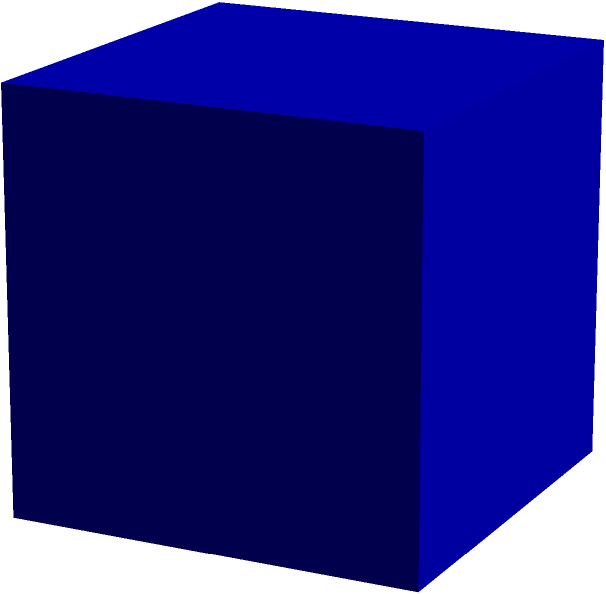In your book club, you're using a cube-shaped display box to showcase a special edition memory book. If the edge length of this cube is $a$ units, what is the volume of the display box? To calculate the volume of a cube, we follow these steps:

1. Identify the formula for the volume of a cube:
   The volume of a cube is given by $V = a^3$, where $a$ is the length of an edge.

2. Understand why this formula works:
   - A cube has three dimensions: length, width, and height.
   - In a cube, all these dimensions are equal to the edge length $a$.
   - To find the volume, we multiply these three dimensions: $a \times a \times a = a^3$

3. Apply the formula:
   - We're given that the edge length is $a$ units.
   - Substituting this into our formula: $V = a^3$

4. Interpret the result:
   - This means that for any edge length $a$, the volume will be $a$ cubed.
   - For example, if $a = 2$ units, the volume would be $2^3 = 8$ cubic units.

Remember, in the context of your book club, this formula can help you quickly determine how much space you have in your display box for memory-related books or materials.
Answer: $V = a^3$ 